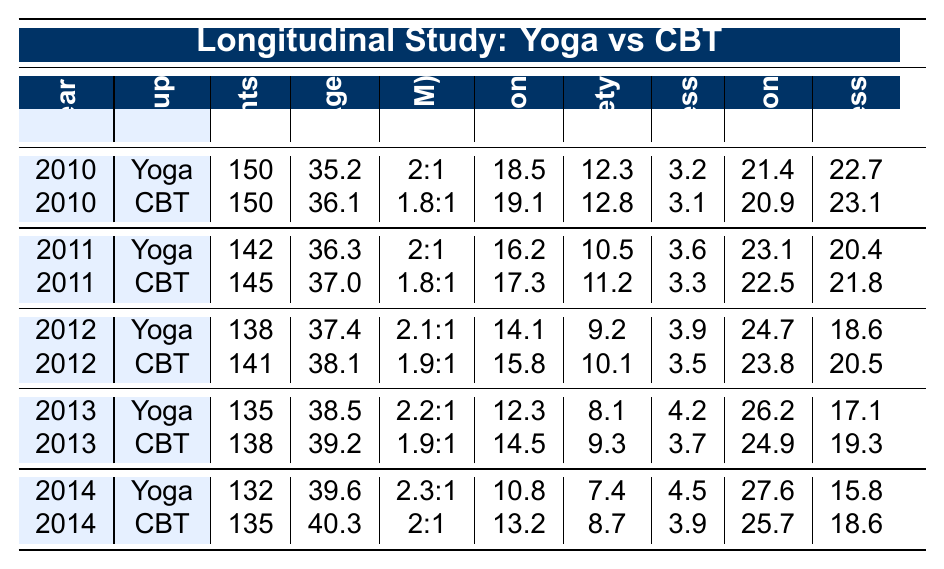What is the average age of participants in the Yoga group in 2012? From the 2012 row for the Yoga group, the average age is indicated as 37.4 years.
Answer: 37.4 What was the depression score for the CBT group in 2013? The depression score for the CBT group in 2013 can be found in the corresponding row, which shows a score of 14.5.
Answer: 14.5 In which year did Yoga practitioners report the lowest average depression score? By examining the depression scores across the years for the Yoga group, the lowest score is 10.8 in 2014.
Answer: 2014 How many participants were involved in the CBT group in 2011? According to the table, the number of participants in the CBT group for 2011 is 145.
Answer: 145 What is the ratio of male to female participants in the Yoga group for the year 2014? The gender ratio for the Yoga group in 2014 is listed as 2.3:1.
Answer: 2.3:1 What is the average life satisfaction score for both groups in 2014? For 2014, the life satisfaction score for the Yoga group is 27.6 and for the CBT group, it is 25.7. The average can be calculated as (27.6 + 25.7)/2 = 26.65.
Answer: 26.65 Is the average anxiety score for the Yoga group lower than for the CBT group in 2011? The average anxiety score for the Yoga group in 2011 is 10.5, while for the CBT group it is 11.2. Since 10.5 is less than 11.2, the statement is true.
Answer: Yes Which group had a higher mindfulness score in 2013? According to the 2013 data, the mindfulness score for the Yoga group is 4.2, and for the CBT group, it is 3.7. Therefore, the Yoga group had a higher score.
Answer: Yoga What has been the trend in the stress level for the Yoga group from 2010 to 2014? The stress levels for the Yoga group from 2010 to 2014 are: 22.7, 20.4, 18.6, 17.1, and 15.8. This indicates a decreasing trend.
Answer: Decreasing What was the difference in average ages between the Yoga and CBT groups in 2012? In 2012, the average age for the Yoga group was 37.4, and for the CBT group, it was 38.1. The difference is calculated as 38.1 - 37.4 = 0.7 years.
Answer: 0.7 